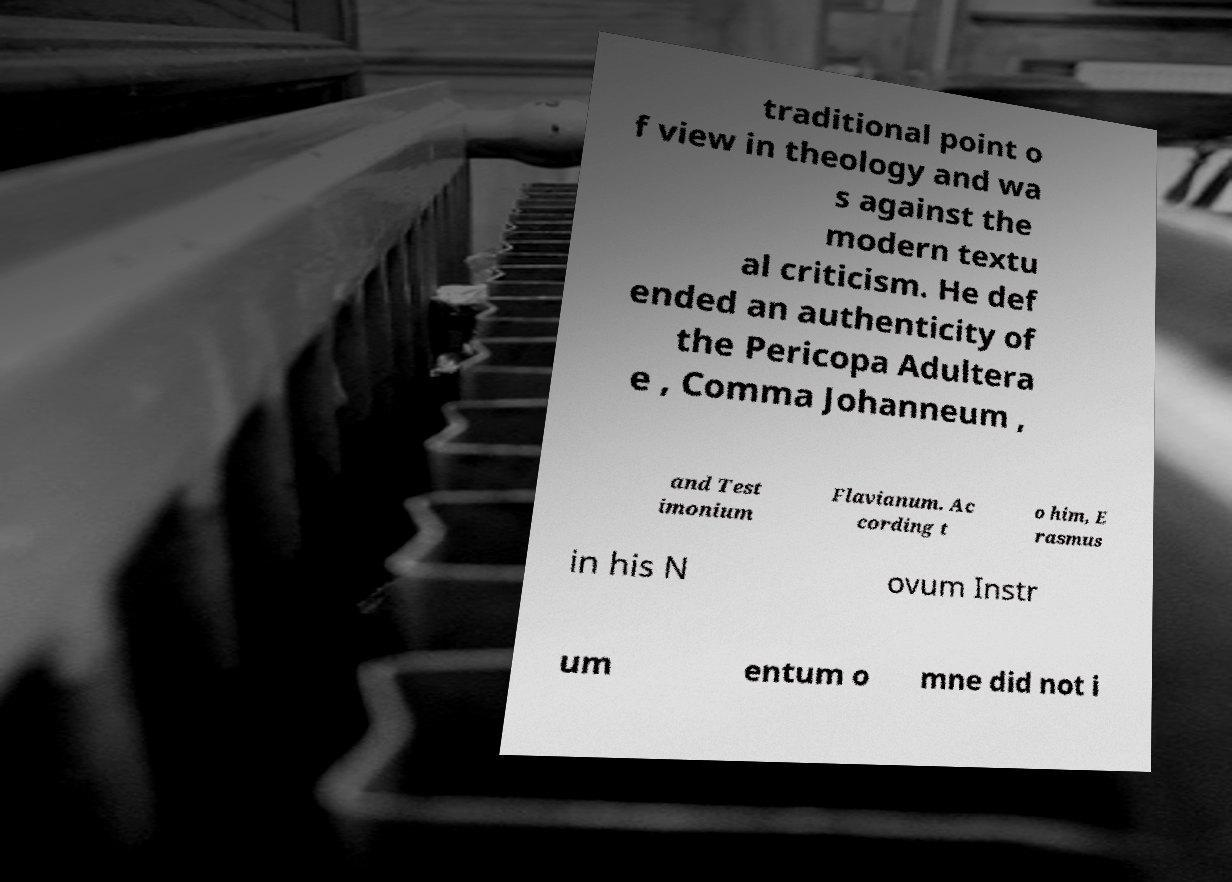For documentation purposes, I need the text within this image transcribed. Could you provide that? traditional point o f view in theology and wa s against the modern textu al criticism. He def ended an authenticity of the Pericopa Adultera e , Comma Johanneum , and Test imonium Flavianum. Ac cording t o him, E rasmus in his N ovum Instr um entum o mne did not i 